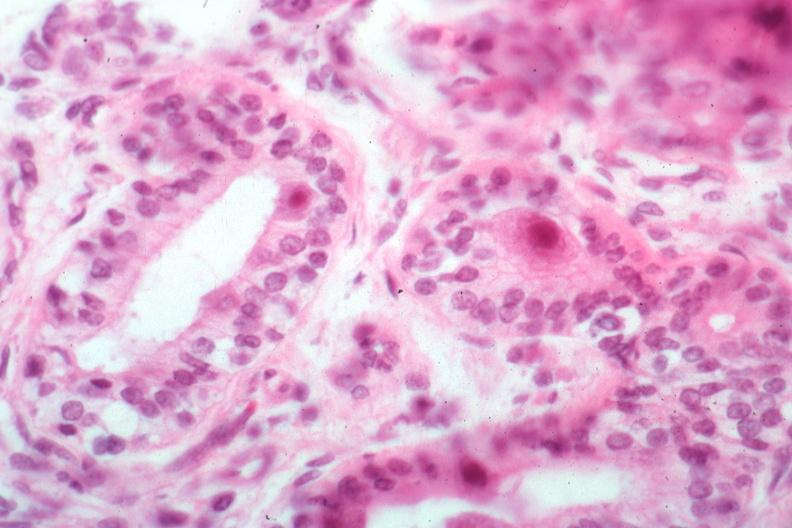where is this?
Answer the question using a single word or phrase. Oral 